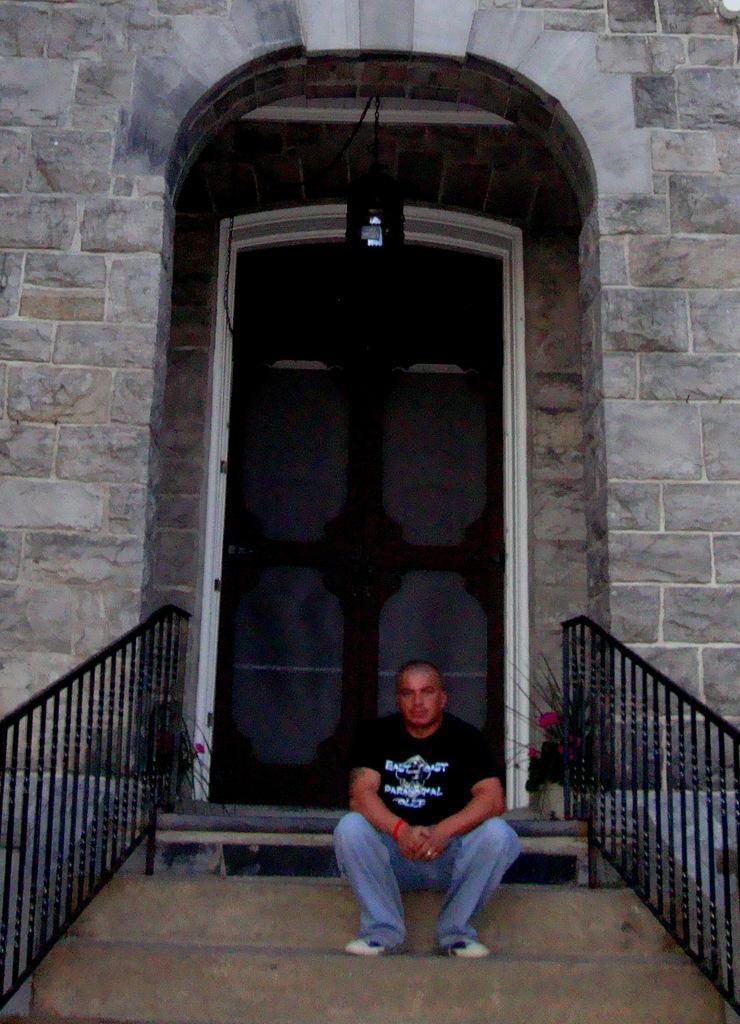In one or two sentences, can you explain what this image depicts? In this picture I can see at the bottom a man is sitting, there are railings on either side of this image, at the top there is an entrance. 